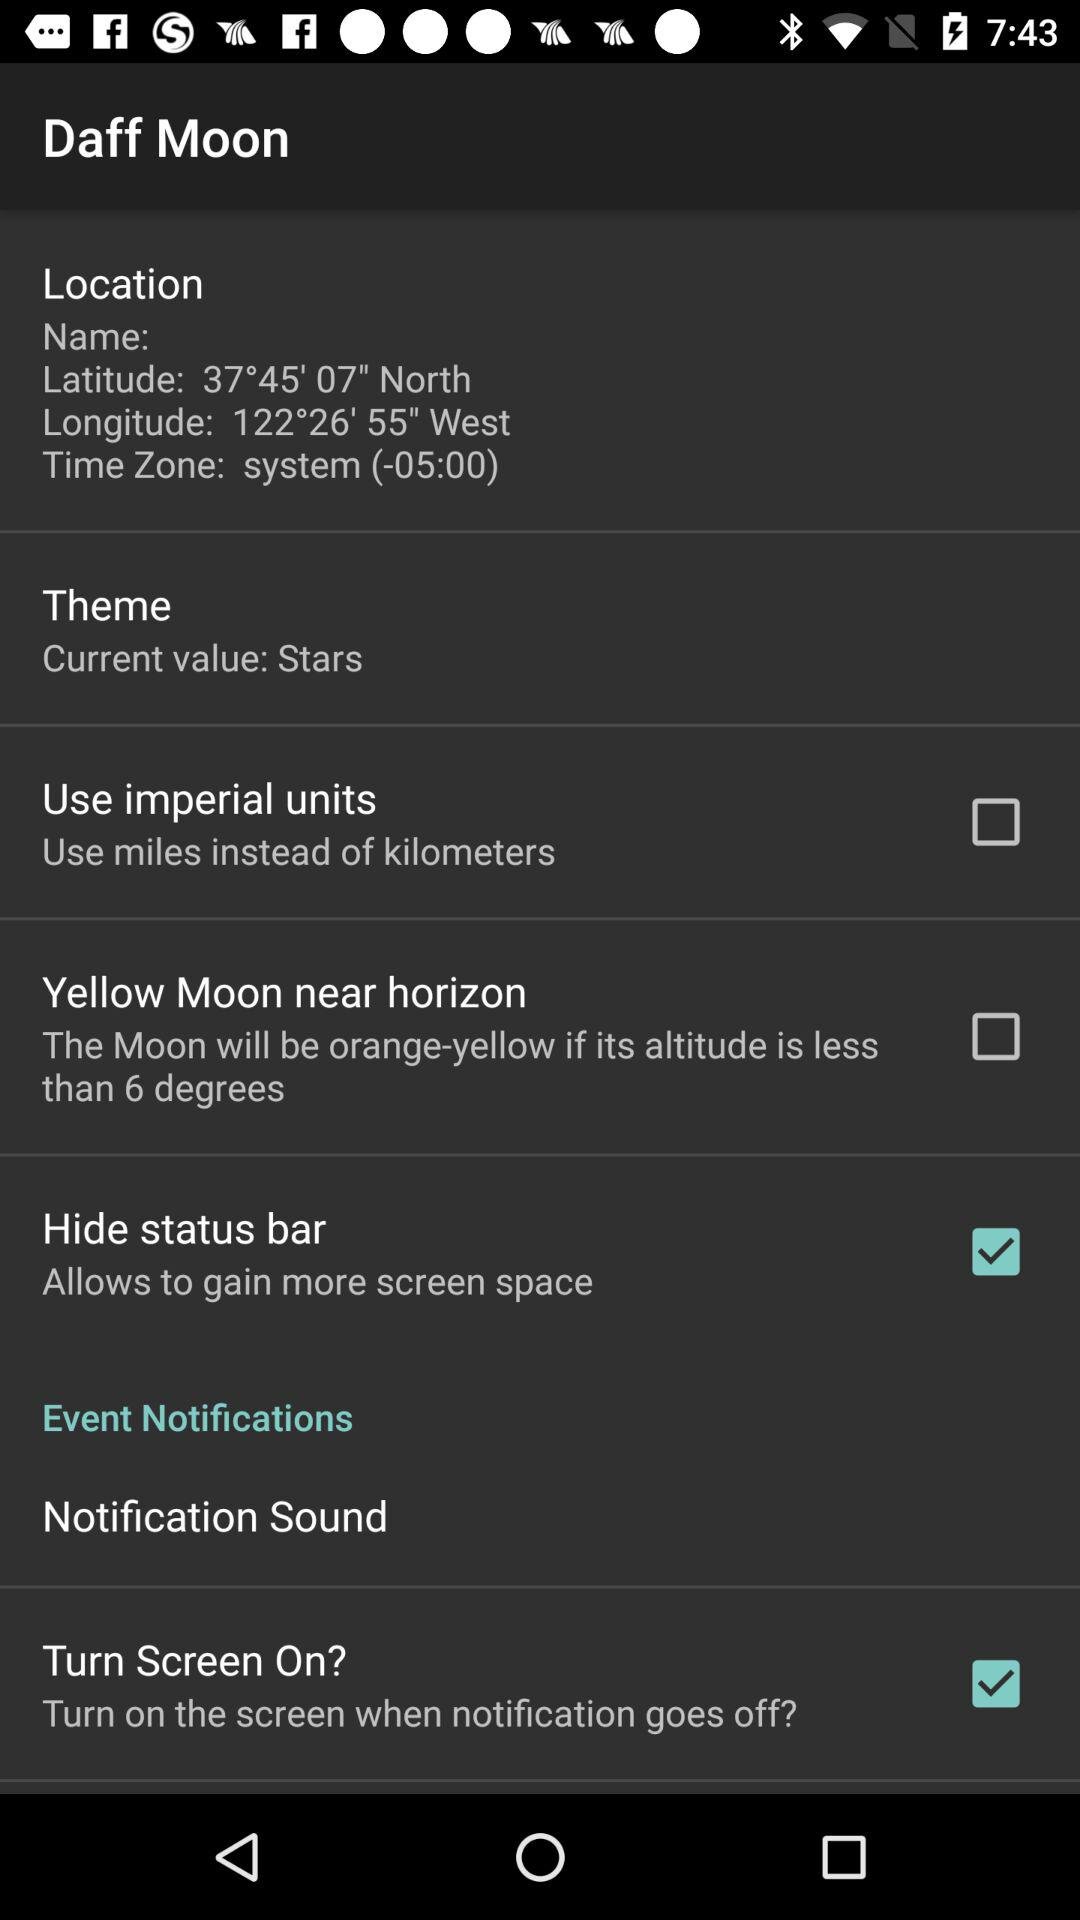Which themes are available to choose from?
When the provided information is insufficient, respond with <no answer>. <no answer> 